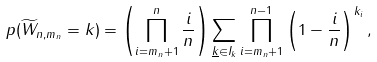<formula> <loc_0><loc_0><loc_500><loc_500>\ p ( \widetilde { W } _ { n , m _ { n } } = k ) = \left ( \prod _ { i = m _ { n } + 1 } ^ { n } \frac { i } { n } \right ) \sum _ { \underline { k } \in I _ { k } } \prod _ { i = m _ { n } + 1 } ^ { n - 1 } \left ( 1 - \frac { i } { n } \right ) ^ { k _ { i } } ,</formula> 